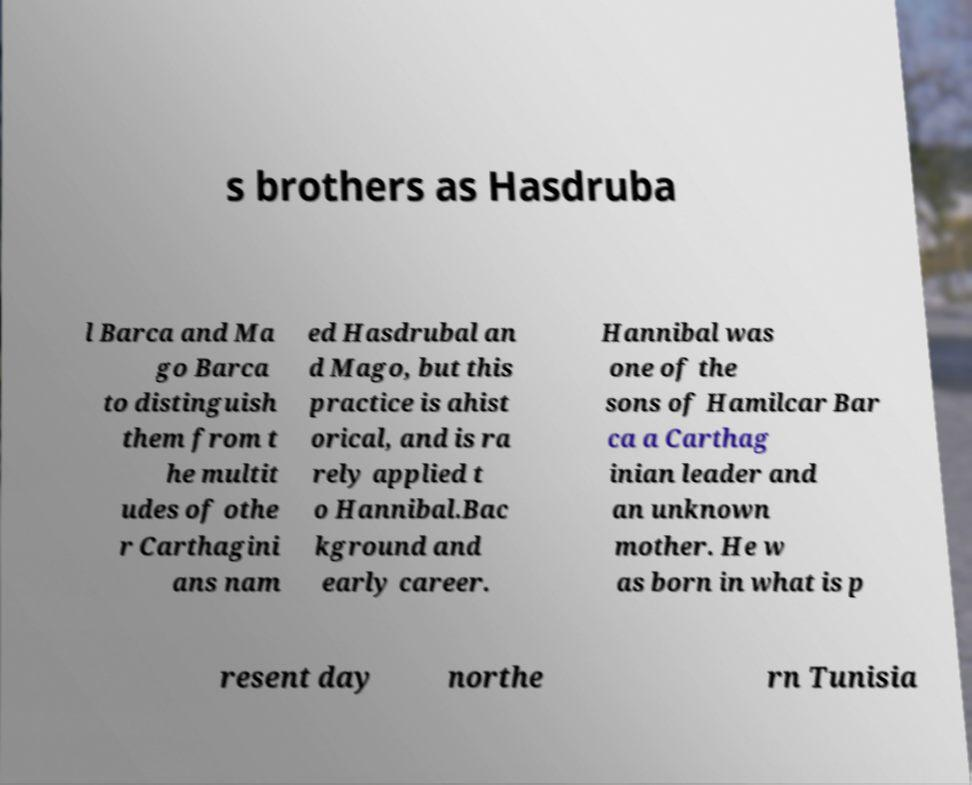Could you assist in decoding the text presented in this image and type it out clearly? s brothers as Hasdruba l Barca and Ma go Barca to distinguish them from t he multit udes of othe r Carthagini ans nam ed Hasdrubal an d Mago, but this practice is ahist orical, and is ra rely applied t o Hannibal.Bac kground and early career. Hannibal was one of the sons of Hamilcar Bar ca a Carthag inian leader and an unknown mother. He w as born in what is p resent day northe rn Tunisia 